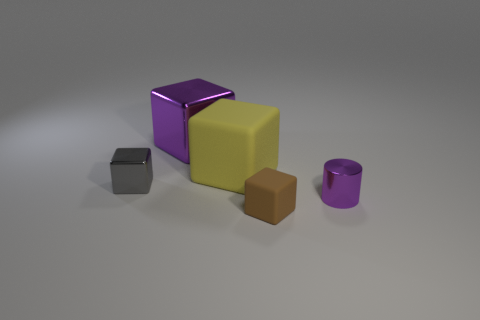What conclusions can be drawn about the textures of the surfaces visible? The image showcases a variety of textures: the yellow and brown objects have matte surfaces that absorb light, while the grey cube and purple objects have reflective surfaces that bounce light back, indicating they're likely smoother. Could the objects in the image serve any particular purpose together, or do they seem randomly placed? The objects seem to be randomly placed with no apparent functional relationship to one another. They appear to be more of a display of shapes and materials, perhaps for an artistic or illustrative purpose. 